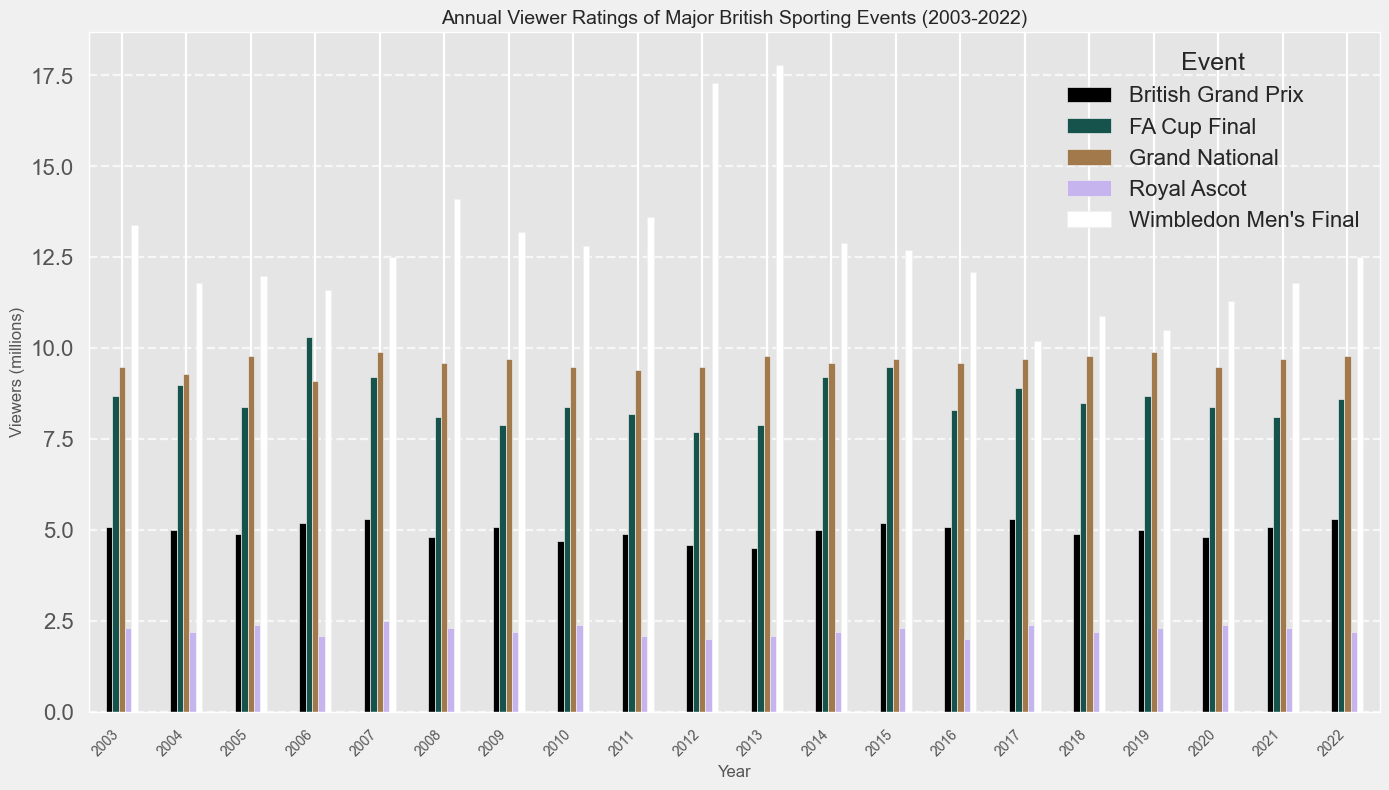Which event had the highest average viewers across all years? To determine which event had the highest average viewers, look across all years for each event and identify the event with the tallest bars. Wimbledon Men's Final consistently has the tallest bars.
Answer: Wimbledon Men's Final How do the viewer ratings for the Wimbledon Men's Final in 2012 compare to those in 2013? Locate the bars representing the viewer ratings for the Wimbledon Men's Final for the years 2012 and 2013. The 2013 bar is slightly higher than the 2012 bar, indicating a higher viewership in 2013.
Answer: 2013 had higher ratings What is the difference in viewers between the FA Cup Final and Wimbledon Men's Final in 2013? Find the bars for the FA Cup Final and Wimbledon Men's Final in 2013. Subtract the height of the FA Cup Final bar from the height of the Wimbledon Men's Final bar.
Answer: 9.9 million Which year saw the highest viewer ratings for the Royal Ascot? Look for the tallest bar in the series for Royal Ascot across all years. The tallest bar appears to be in 2007.
Answer: 2007 Is there a trend in viewership for the Grand National over the years? Observe the height of the bars for the Grand National over the years. The bars remain quite steady with minor fluctuations, indicating a relatively stable viewership trend.
Answer: Stable trend In which year did the British Grand Prix receive the lowest number of viewers? Identify the shortest bar in the series representing the British Grand Prix. The shortest bar corresponds to 2013.
Answer: 2013 How many years did the FA Cup Final have more than 9 million viewers? Count the number of bars taller than the 9 million mark in the series representing the FA Cup Final. These bars appear in several years.
Answer: 9 years Which event shows the most significant drop in viewership comparing 2016 to 2017? Compare the heights of the bars for each event between 2016 and 2017. The Wimbledon Men's Final has the most significant drop, as seen by the steep decrease in the bar height.
Answer: Wimbledon Men's Final What is the average viewership for the British Grand Prix in the years 2010 and 2011? Add the viewer ratings for the British Grand Prix in 2010 (4.7) and 2011 (4.9), then divide by 2. Average = (4.7 + 4.9) / 2.
Answer: 4.8 million 